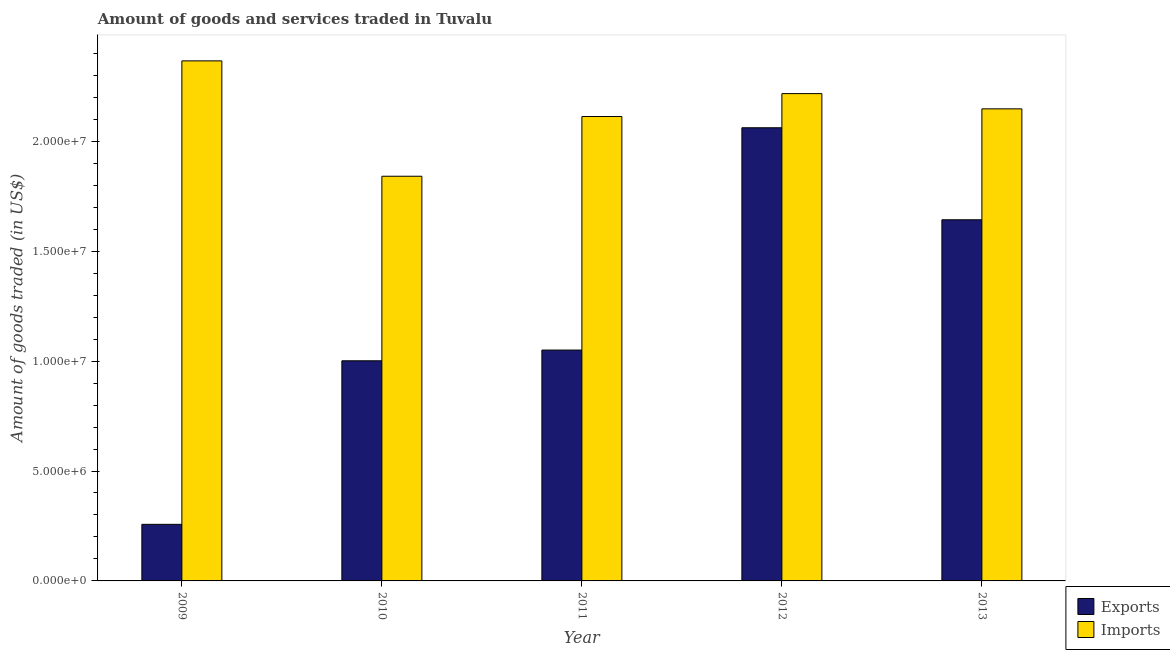How many different coloured bars are there?
Your answer should be compact. 2. Are the number of bars per tick equal to the number of legend labels?
Offer a terse response. Yes. Are the number of bars on each tick of the X-axis equal?
Keep it short and to the point. Yes. How many bars are there on the 1st tick from the left?
Provide a succinct answer. 2. What is the label of the 2nd group of bars from the left?
Provide a short and direct response. 2010. In how many cases, is the number of bars for a given year not equal to the number of legend labels?
Make the answer very short. 0. What is the amount of goods exported in 2009?
Your answer should be very brief. 2.57e+06. Across all years, what is the maximum amount of goods exported?
Provide a short and direct response. 2.06e+07. Across all years, what is the minimum amount of goods imported?
Offer a terse response. 1.84e+07. In which year was the amount of goods exported maximum?
Ensure brevity in your answer.  2012. What is the total amount of goods imported in the graph?
Provide a short and direct response. 1.07e+08. What is the difference between the amount of goods imported in 2012 and that in 2013?
Keep it short and to the point. 6.94e+05. What is the difference between the amount of goods exported in 2013 and the amount of goods imported in 2010?
Offer a terse response. 6.42e+06. What is the average amount of goods imported per year?
Ensure brevity in your answer.  2.14e+07. In the year 2009, what is the difference between the amount of goods exported and amount of goods imported?
Your answer should be very brief. 0. In how many years, is the amount of goods exported greater than 3000000 US$?
Give a very brief answer. 4. What is the ratio of the amount of goods exported in 2009 to that in 2012?
Ensure brevity in your answer.  0.12. What is the difference between the highest and the second highest amount of goods exported?
Keep it short and to the point. 4.19e+06. What is the difference between the highest and the lowest amount of goods imported?
Offer a very short reply. 5.25e+06. What does the 2nd bar from the left in 2012 represents?
Your response must be concise. Imports. What does the 2nd bar from the right in 2009 represents?
Give a very brief answer. Exports. How many bars are there?
Make the answer very short. 10. Are all the bars in the graph horizontal?
Give a very brief answer. No. What is the difference between two consecutive major ticks on the Y-axis?
Your response must be concise. 5.00e+06. Are the values on the major ticks of Y-axis written in scientific E-notation?
Your answer should be very brief. Yes. Does the graph contain any zero values?
Your response must be concise. No. What is the title of the graph?
Offer a terse response. Amount of goods and services traded in Tuvalu. Does "Secondary education" appear as one of the legend labels in the graph?
Your answer should be compact. No. What is the label or title of the Y-axis?
Provide a succinct answer. Amount of goods traded (in US$). What is the Amount of goods traded (in US$) of Exports in 2009?
Your response must be concise. 2.57e+06. What is the Amount of goods traded (in US$) of Imports in 2009?
Offer a very short reply. 2.37e+07. What is the Amount of goods traded (in US$) of Exports in 2010?
Your response must be concise. 1.00e+07. What is the Amount of goods traded (in US$) of Imports in 2010?
Give a very brief answer. 1.84e+07. What is the Amount of goods traded (in US$) of Exports in 2011?
Provide a succinct answer. 1.05e+07. What is the Amount of goods traded (in US$) in Imports in 2011?
Offer a terse response. 2.11e+07. What is the Amount of goods traded (in US$) in Exports in 2012?
Make the answer very short. 2.06e+07. What is the Amount of goods traded (in US$) in Imports in 2012?
Provide a short and direct response. 2.22e+07. What is the Amount of goods traded (in US$) of Exports in 2013?
Provide a succinct answer. 1.64e+07. What is the Amount of goods traded (in US$) of Imports in 2013?
Your answer should be very brief. 2.15e+07. Across all years, what is the maximum Amount of goods traded (in US$) in Exports?
Your response must be concise. 2.06e+07. Across all years, what is the maximum Amount of goods traded (in US$) in Imports?
Your answer should be very brief. 2.37e+07. Across all years, what is the minimum Amount of goods traded (in US$) of Exports?
Offer a very short reply. 2.57e+06. Across all years, what is the minimum Amount of goods traded (in US$) in Imports?
Provide a short and direct response. 1.84e+07. What is the total Amount of goods traded (in US$) of Exports in the graph?
Offer a terse response. 6.01e+07. What is the total Amount of goods traded (in US$) of Imports in the graph?
Keep it short and to the point. 1.07e+08. What is the difference between the Amount of goods traded (in US$) of Exports in 2009 and that in 2010?
Your answer should be compact. -7.44e+06. What is the difference between the Amount of goods traded (in US$) in Imports in 2009 and that in 2010?
Your answer should be compact. 5.25e+06. What is the difference between the Amount of goods traded (in US$) of Exports in 2009 and that in 2011?
Provide a succinct answer. -7.93e+06. What is the difference between the Amount of goods traded (in US$) in Imports in 2009 and that in 2011?
Provide a short and direct response. 2.53e+06. What is the difference between the Amount of goods traded (in US$) in Exports in 2009 and that in 2012?
Offer a terse response. -1.80e+07. What is the difference between the Amount of goods traded (in US$) in Imports in 2009 and that in 2012?
Keep it short and to the point. 1.49e+06. What is the difference between the Amount of goods traded (in US$) of Exports in 2009 and that in 2013?
Your response must be concise. -1.39e+07. What is the difference between the Amount of goods traded (in US$) in Imports in 2009 and that in 2013?
Make the answer very short. 2.18e+06. What is the difference between the Amount of goods traded (in US$) of Exports in 2010 and that in 2011?
Offer a terse response. -4.88e+05. What is the difference between the Amount of goods traded (in US$) in Imports in 2010 and that in 2011?
Your response must be concise. -2.72e+06. What is the difference between the Amount of goods traded (in US$) of Exports in 2010 and that in 2012?
Your answer should be compact. -1.06e+07. What is the difference between the Amount of goods traded (in US$) in Imports in 2010 and that in 2012?
Keep it short and to the point. -3.76e+06. What is the difference between the Amount of goods traded (in US$) of Exports in 2010 and that in 2013?
Your answer should be very brief. -6.42e+06. What is the difference between the Amount of goods traded (in US$) in Imports in 2010 and that in 2013?
Give a very brief answer. -3.07e+06. What is the difference between the Amount of goods traded (in US$) of Exports in 2011 and that in 2012?
Your response must be concise. -1.01e+07. What is the difference between the Amount of goods traded (in US$) in Imports in 2011 and that in 2012?
Give a very brief answer. -1.04e+06. What is the difference between the Amount of goods traded (in US$) in Exports in 2011 and that in 2013?
Your answer should be compact. -5.93e+06. What is the difference between the Amount of goods traded (in US$) of Imports in 2011 and that in 2013?
Provide a short and direct response. -3.49e+05. What is the difference between the Amount of goods traded (in US$) of Exports in 2012 and that in 2013?
Make the answer very short. 4.19e+06. What is the difference between the Amount of goods traded (in US$) in Imports in 2012 and that in 2013?
Your answer should be compact. 6.94e+05. What is the difference between the Amount of goods traded (in US$) of Exports in 2009 and the Amount of goods traded (in US$) of Imports in 2010?
Give a very brief answer. -1.58e+07. What is the difference between the Amount of goods traded (in US$) of Exports in 2009 and the Amount of goods traded (in US$) of Imports in 2011?
Provide a short and direct response. -1.86e+07. What is the difference between the Amount of goods traded (in US$) of Exports in 2009 and the Amount of goods traded (in US$) of Imports in 2012?
Make the answer very short. -1.96e+07. What is the difference between the Amount of goods traded (in US$) of Exports in 2009 and the Amount of goods traded (in US$) of Imports in 2013?
Keep it short and to the point. -1.89e+07. What is the difference between the Amount of goods traded (in US$) in Exports in 2010 and the Amount of goods traded (in US$) in Imports in 2011?
Make the answer very short. -1.11e+07. What is the difference between the Amount of goods traded (in US$) of Exports in 2010 and the Amount of goods traded (in US$) of Imports in 2012?
Provide a succinct answer. -1.22e+07. What is the difference between the Amount of goods traded (in US$) of Exports in 2010 and the Amount of goods traded (in US$) of Imports in 2013?
Your response must be concise. -1.15e+07. What is the difference between the Amount of goods traded (in US$) in Exports in 2011 and the Amount of goods traded (in US$) in Imports in 2012?
Ensure brevity in your answer.  -1.17e+07. What is the difference between the Amount of goods traded (in US$) in Exports in 2011 and the Amount of goods traded (in US$) in Imports in 2013?
Your response must be concise. -1.10e+07. What is the difference between the Amount of goods traded (in US$) of Exports in 2012 and the Amount of goods traded (in US$) of Imports in 2013?
Make the answer very short. -8.60e+05. What is the average Amount of goods traded (in US$) in Exports per year?
Your answer should be compact. 1.20e+07. What is the average Amount of goods traded (in US$) in Imports per year?
Make the answer very short. 2.14e+07. In the year 2009, what is the difference between the Amount of goods traded (in US$) of Exports and Amount of goods traded (in US$) of Imports?
Provide a short and direct response. -2.11e+07. In the year 2010, what is the difference between the Amount of goods traded (in US$) in Exports and Amount of goods traded (in US$) in Imports?
Keep it short and to the point. -8.40e+06. In the year 2011, what is the difference between the Amount of goods traded (in US$) of Exports and Amount of goods traded (in US$) of Imports?
Offer a terse response. -1.06e+07. In the year 2012, what is the difference between the Amount of goods traded (in US$) of Exports and Amount of goods traded (in US$) of Imports?
Your answer should be very brief. -1.55e+06. In the year 2013, what is the difference between the Amount of goods traded (in US$) in Exports and Amount of goods traded (in US$) in Imports?
Your answer should be very brief. -5.05e+06. What is the ratio of the Amount of goods traded (in US$) in Exports in 2009 to that in 2010?
Provide a succinct answer. 0.26. What is the ratio of the Amount of goods traded (in US$) in Imports in 2009 to that in 2010?
Make the answer very short. 1.29. What is the ratio of the Amount of goods traded (in US$) of Exports in 2009 to that in 2011?
Ensure brevity in your answer.  0.25. What is the ratio of the Amount of goods traded (in US$) in Imports in 2009 to that in 2011?
Offer a terse response. 1.12. What is the ratio of the Amount of goods traded (in US$) of Exports in 2009 to that in 2012?
Provide a short and direct response. 0.12. What is the ratio of the Amount of goods traded (in US$) in Imports in 2009 to that in 2012?
Give a very brief answer. 1.07. What is the ratio of the Amount of goods traded (in US$) of Exports in 2009 to that in 2013?
Offer a very short reply. 0.16. What is the ratio of the Amount of goods traded (in US$) of Imports in 2009 to that in 2013?
Your response must be concise. 1.1. What is the ratio of the Amount of goods traded (in US$) in Exports in 2010 to that in 2011?
Your answer should be compact. 0.95. What is the ratio of the Amount of goods traded (in US$) in Imports in 2010 to that in 2011?
Keep it short and to the point. 0.87. What is the ratio of the Amount of goods traded (in US$) of Exports in 2010 to that in 2012?
Give a very brief answer. 0.49. What is the ratio of the Amount of goods traded (in US$) of Imports in 2010 to that in 2012?
Ensure brevity in your answer.  0.83. What is the ratio of the Amount of goods traded (in US$) of Exports in 2010 to that in 2013?
Offer a terse response. 0.61. What is the ratio of the Amount of goods traded (in US$) of Imports in 2010 to that in 2013?
Provide a succinct answer. 0.86. What is the ratio of the Amount of goods traded (in US$) in Exports in 2011 to that in 2012?
Your answer should be compact. 0.51. What is the ratio of the Amount of goods traded (in US$) of Imports in 2011 to that in 2012?
Provide a short and direct response. 0.95. What is the ratio of the Amount of goods traded (in US$) of Exports in 2011 to that in 2013?
Offer a very short reply. 0.64. What is the ratio of the Amount of goods traded (in US$) in Imports in 2011 to that in 2013?
Offer a very short reply. 0.98. What is the ratio of the Amount of goods traded (in US$) of Exports in 2012 to that in 2013?
Make the answer very short. 1.25. What is the ratio of the Amount of goods traded (in US$) of Imports in 2012 to that in 2013?
Provide a short and direct response. 1.03. What is the difference between the highest and the second highest Amount of goods traded (in US$) in Exports?
Your response must be concise. 4.19e+06. What is the difference between the highest and the second highest Amount of goods traded (in US$) of Imports?
Provide a short and direct response. 1.49e+06. What is the difference between the highest and the lowest Amount of goods traded (in US$) of Exports?
Make the answer very short. 1.80e+07. What is the difference between the highest and the lowest Amount of goods traded (in US$) of Imports?
Your response must be concise. 5.25e+06. 